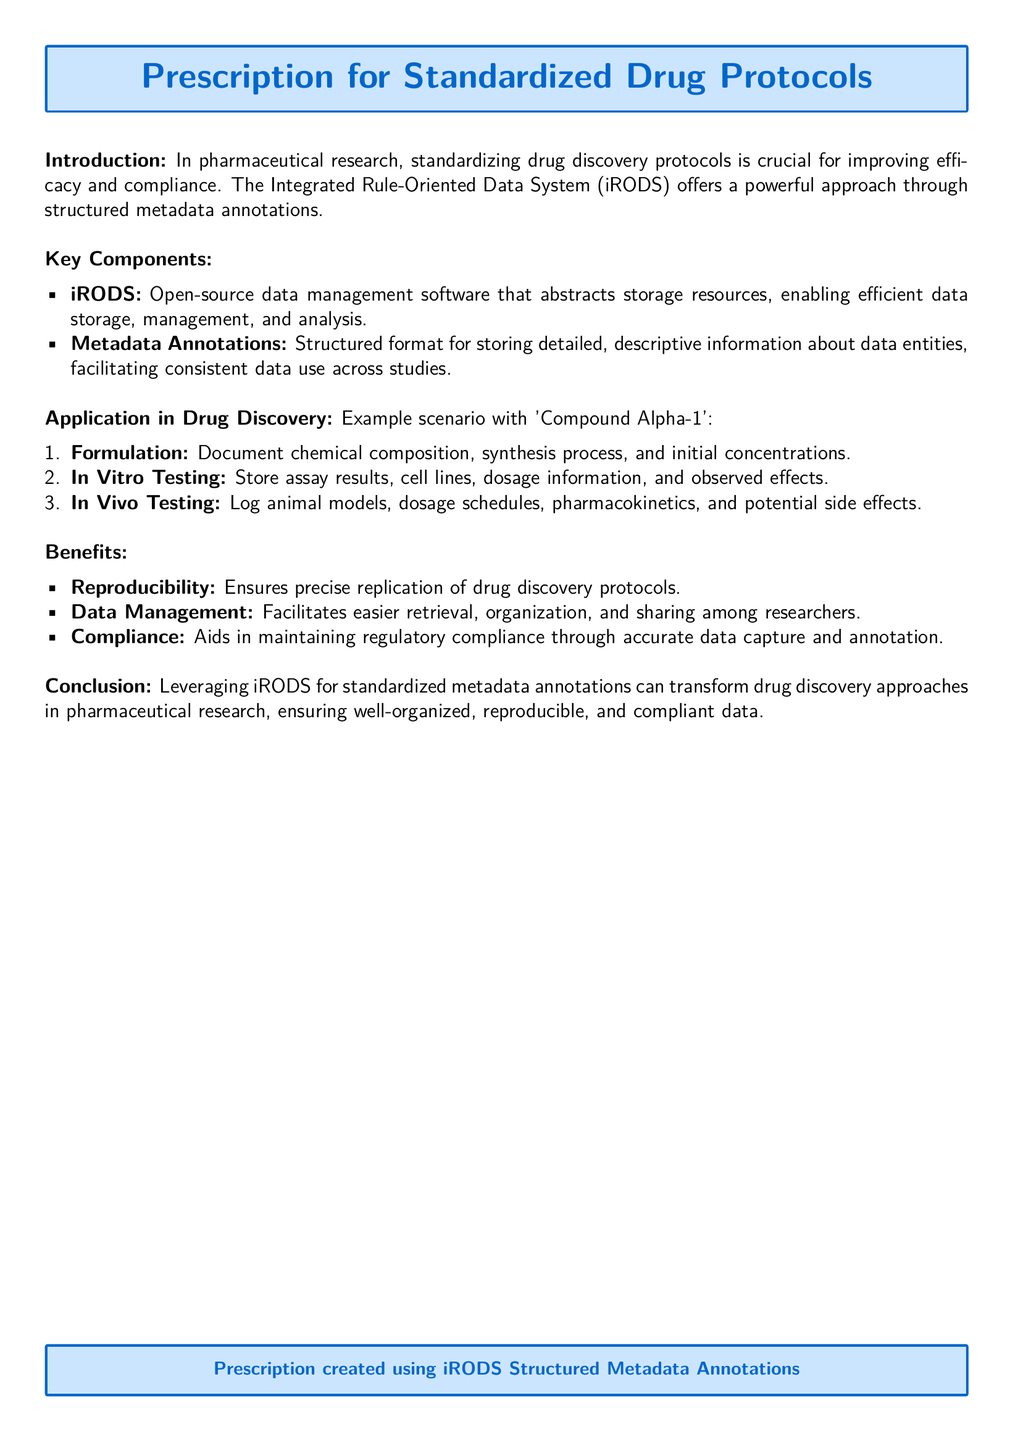What is the title of the document? The title is prominently displayed in a formatted box at the top of the document.
Answer: Prescription for Standardized Drug Protocols What software is mentioned in the document? The document specifically identifies iRODS as the key software for data management.
Answer: iRODS What is a key benefit of using standardized drug protocols? The document lists reproducibility as one of the main benefits.
Answer: Reproducibility How many application scenarios are provided in the document? The document outlines three application scenarios pertaining to drug discovery protocols.
Answer: Three What is the main focus of the introduction? The introduction highlights the importance of standardizing drug discovery protocols for compliance and efficacy.
Answer: Standardizing drug discovery protocols What information is suggested to be documented under formulation? The document specifies that chemical composition, synthesis process, and initial concentrations should be documented.
Answer: Chemical composition, synthesis process, initial concentrations What type of testing is mentioned first in the application section? The document first mentions In Vitro Testing in the application scenario list.
Answer: In Vitro Testing What captures the essence of leveraging iRODS in drug discovery? The conclusion points out that iRODS can transform drug discovery approaches through structured annotations.
Answer: Transform drug discovery approaches 